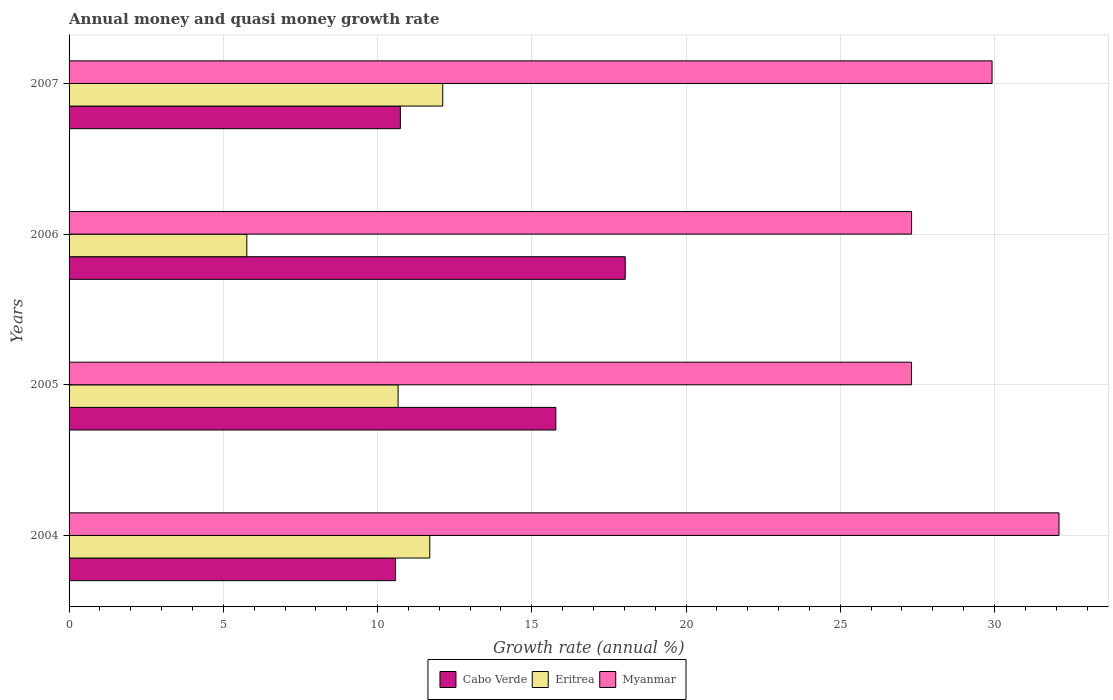How many different coloured bars are there?
Keep it short and to the point. 3. How many groups of bars are there?
Offer a terse response. 4. Are the number of bars on each tick of the Y-axis equal?
Your answer should be very brief. Yes. How many bars are there on the 1st tick from the top?
Ensure brevity in your answer.  3. How many bars are there on the 2nd tick from the bottom?
Provide a short and direct response. 3. In how many cases, is the number of bars for a given year not equal to the number of legend labels?
Provide a short and direct response. 0. What is the growth rate in Eritrea in 2006?
Offer a very short reply. 5.76. Across all years, what is the maximum growth rate in Cabo Verde?
Your answer should be compact. 18.03. Across all years, what is the minimum growth rate in Eritrea?
Provide a succinct answer. 5.76. In which year was the growth rate in Myanmar maximum?
Give a very brief answer. 2004. What is the total growth rate in Myanmar in the graph?
Offer a very short reply. 116.63. What is the difference between the growth rate in Myanmar in 2005 and that in 2006?
Ensure brevity in your answer.  -0. What is the difference between the growth rate in Myanmar in 2006 and the growth rate in Cabo Verde in 2007?
Ensure brevity in your answer.  16.57. What is the average growth rate in Cabo Verde per year?
Your answer should be very brief. 13.78. In the year 2004, what is the difference between the growth rate in Myanmar and growth rate in Eritrea?
Make the answer very short. 20.4. In how many years, is the growth rate in Myanmar greater than 10 %?
Offer a terse response. 4. What is the ratio of the growth rate in Eritrea in 2005 to that in 2006?
Your answer should be compact. 1.85. Is the growth rate in Eritrea in 2004 less than that in 2007?
Keep it short and to the point. Yes. Is the difference between the growth rate in Myanmar in 2006 and 2007 greater than the difference between the growth rate in Eritrea in 2006 and 2007?
Provide a succinct answer. Yes. What is the difference between the highest and the second highest growth rate in Cabo Verde?
Your answer should be compact. 2.25. What is the difference between the highest and the lowest growth rate in Eritrea?
Ensure brevity in your answer.  6.35. In how many years, is the growth rate in Cabo Verde greater than the average growth rate in Cabo Verde taken over all years?
Ensure brevity in your answer.  2. Is the sum of the growth rate in Myanmar in 2005 and 2006 greater than the maximum growth rate in Eritrea across all years?
Make the answer very short. Yes. What does the 1st bar from the top in 2006 represents?
Your answer should be compact. Myanmar. What does the 1st bar from the bottom in 2004 represents?
Offer a terse response. Cabo Verde. Is it the case that in every year, the sum of the growth rate in Eritrea and growth rate in Cabo Verde is greater than the growth rate in Myanmar?
Ensure brevity in your answer.  No. How many bars are there?
Give a very brief answer. 12. Are all the bars in the graph horizontal?
Offer a very short reply. Yes. How many years are there in the graph?
Provide a short and direct response. 4. What is the difference between two consecutive major ticks on the X-axis?
Keep it short and to the point. 5. Does the graph contain grids?
Offer a very short reply. Yes. Where does the legend appear in the graph?
Your response must be concise. Bottom center. How many legend labels are there?
Ensure brevity in your answer.  3. How are the legend labels stacked?
Provide a short and direct response. Horizontal. What is the title of the graph?
Provide a short and direct response. Annual money and quasi money growth rate. What is the label or title of the X-axis?
Provide a short and direct response. Growth rate (annual %). What is the Growth rate (annual %) in Cabo Verde in 2004?
Give a very brief answer. 10.58. What is the Growth rate (annual %) of Eritrea in 2004?
Provide a succinct answer. 11.69. What is the Growth rate (annual %) of Myanmar in 2004?
Ensure brevity in your answer.  32.09. What is the Growth rate (annual %) of Cabo Verde in 2005?
Keep it short and to the point. 15.78. What is the Growth rate (annual %) of Eritrea in 2005?
Give a very brief answer. 10.67. What is the Growth rate (annual %) of Myanmar in 2005?
Your answer should be very brief. 27.31. What is the Growth rate (annual %) in Cabo Verde in 2006?
Make the answer very short. 18.03. What is the Growth rate (annual %) of Eritrea in 2006?
Provide a short and direct response. 5.76. What is the Growth rate (annual %) of Myanmar in 2006?
Your answer should be very brief. 27.31. What is the Growth rate (annual %) of Cabo Verde in 2007?
Your answer should be very brief. 10.74. What is the Growth rate (annual %) in Eritrea in 2007?
Offer a very short reply. 12.11. What is the Growth rate (annual %) in Myanmar in 2007?
Offer a very short reply. 29.92. Across all years, what is the maximum Growth rate (annual %) in Cabo Verde?
Offer a very short reply. 18.03. Across all years, what is the maximum Growth rate (annual %) of Eritrea?
Your response must be concise. 12.11. Across all years, what is the maximum Growth rate (annual %) in Myanmar?
Ensure brevity in your answer.  32.09. Across all years, what is the minimum Growth rate (annual %) of Cabo Verde?
Give a very brief answer. 10.58. Across all years, what is the minimum Growth rate (annual %) in Eritrea?
Your answer should be compact. 5.76. Across all years, what is the minimum Growth rate (annual %) of Myanmar?
Your answer should be very brief. 27.31. What is the total Growth rate (annual %) in Cabo Verde in the graph?
Your answer should be very brief. 55.13. What is the total Growth rate (annual %) in Eritrea in the graph?
Provide a succinct answer. 40.24. What is the total Growth rate (annual %) in Myanmar in the graph?
Your answer should be very brief. 116.63. What is the difference between the Growth rate (annual %) of Cabo Verde in 2004 and that in 2005?
Offer a terse response. -5.2. What is the difference between the Growth rate (annual %) of Eritrea in 2004 and that in 2005?
Offer a terse response. 1.03. What is the difference between the Growth rate (annual %) of Myanmar in 2004 and that in 2005?
Make the answer very short. 4.78. What is the difference between the Growth rate (annual %) in Cabo Verde in 2004 and that in 2006?
Your response must be concise. -7.45. What is the difference between the Growth rate (annual %) of Eritrea in 2004 and that in 2006?
Give a very brief answer. 5.93. What is the difference between the Growth rate (annual %) of Myanmar in 2004 and that in 2006?
Your answer should be compact. 4.78. What is the difference between the Growth rate (annual %) of Cabo Verde in 2004 and that in 2007?
Your answer should be very brief. -0.16. What is the difference between the Growth rate (annual %) of Eritrea in 2004 and that in 2007?
Make the answer very short. -0.42. What is the difference between the Growth rate (annual %) in Myanmar in 2004 and that in 2007?
Your response must be concise. 2.17. What is the difference between the Growth rate (annual %) in Cabo Verde in 2005 and that in 2006?
Your answer should be very brief. -2.25. What is the difference between the Growth rate (annual %) of Eritrea in 2005 and that in 2006?
Provide a succinct answer. 4.9. What is the difference between the Growth rate (annual %) of Myanmar in 2005 and that in 2006?
Your answer should be very brief. -0. What is the difference between the Growth rate (annual %) of Cabo Verde in 2005 and that in 2007?
Make the answer very short. 5.04. What is the difference between the Growth rate (annual %) in Eritrea in 2005 and that in 2007?
Offer a terse response. -1.45. What is the difference between the Growth rate (annual %) in Myanmar in 2005 and that in 2007?
Your response must be concise. -2.61. What is the difference between the Growth rate (annual %) in Cabo Verde in 2006 and that in 2007?
Make the answer very short. 7.29. What is the difference between the Growth rate (annual %) of Eritrea in 2006 and that in 2007?
Ensure brevity in your answer.  -6.35. What is the difference between the Growth rate (annual %) of Myanmar in 2006 and that in 2007?
Your answer should be compact. -2.61. What is the difference between the Growth rate (annual %) in Cabo Verde in 2004 and the Growth rate (annual %) in Eritrea in 2005?
Offer a very short reply. -0.08. What is the difference between the Growth rate (annual %) of Cabo Verde in 2004 and the Growth rate (annual %) of Myanmar in 2005?
Make the answer very short. -16.73. What is the difference between the Growth rate (annual %) in Eritrea in 2004 and the Growth rate (annual %) in Myanmar in 2005?
Offer a terse response. -15.62. What is the difference between the Growth rate (annual %) of Cabo Verde in 2004 and the Growth rate (annual %) of Eritrea in 2006?
Provide a short and direct response. 4.82. What is the difference between the Growth rate (annual %) of Cabo Verde in 2004 and the Growth rate (annual %) of Myanmar in 2006?
Provide a short and direct response. -16.73. What is the difference between the Growth rate (annual %) of Eritrea in 2004 and the Growth rate (annual %) of Myanmar in 2006?
Offer a very short reply. -15.62. What is the difference between the Growth rate (annual %) of Cabo Verde in 2004 and the Growth rate (annual %) of Eritrea in 2007?
Keep it short and to the point. -1.53. What is the difference between the Growth rate (annual %) of Cabo Verde in 2004 and the Growth rate (annual %) of Myanmar in 2007?
Keep it short and to the point. -19.34. What is the difference between the Growth rate (annual %) in Eritrea in 2004 and the Growth rate (annual %) in Myanmar in 2007?
Ensure brevity in your answer.  -18.23. What is the difference between the Growth rate (annual %) in Cabo Verde in 2005 and the Growth rate (annual %) in Eritrea in 2006?
Give a very brief answer. 10.02. What is the difference between the Growth rate (annual %) in Cabo Verde in 2005 and the Growth rate (annual %) in Myanmar in 2006?
Your answer should be compact. -11.53. What is the difference between the Growth rate (annual %) of Eritrea in 2005 and the Growth rate (annual %) of Myanmar in 2006?
Provide a succinct answer. -16.65. What is the difference between the Growth rate (annual %) of Cabo Verde in 2005 and the Growth rate (annual %) of Eritrea in 2007?
Offer a very short reply. 3.67. What is the difference between the Growth rate (annual %) of Cabo Verde in 2005 and the Growth rate (annual %) of Myanmar in 2007?
Your answer should be compact. -14.14. What is the difference between the Growth rate (annual %) in Eritrea in 2005 and the Growth rate (annual %) in Myanmar in 2007?
Your answer should be very brief. -19.25. What is the difference between the Growth rate (annual %) in Cabo Verde in 2006 and the Growth rate (annual %) in Eritrea in 2007?
Keep it short and to the point. 5.92. What is the difference between the Growth rate (annual %) in Cabo Verde in 2006 and the Growth rate (annual %) in Myanmar in 2007?
Keep it short and to the point. -11.89. What is the difference between the Growth rate (annual %) in Eritrea in 2006 and the Growth rate (annual %) in Myanmar in 2007?
Your answer should be compact. -24.16. What is the average Growth rate (annual %) in Cabo Verde per year?
Keep it short and to the point. 13.78. What is the average Growth rate (annual %) of Eritrea per year?
Your answer should be compact. 10.06. What is the average Growth rate (annual %) in Myanmar per year?
Offer a very short reply. 29.16. In the year 2004, what is the difference between the Growth rate (annual %) of Cabo Verde and Growth rate (annual %) of Eritrea?
Offer a terse response. -1.11. In the year 2004, what is the difference between the Growth rate (annual %) in Cabo Verde and Growth rate (annual %) in Myanmar?
Your answer should be very brief. -21.51. In the year 2004, what is the difference between the Growth rate (annual %) in Eritrea and Growth rate (annual %) in Myanmar?
Your response must be concise. -20.4. In the year 2005, what is the difference between the Growth rate (annual %) of Cabo Verde and Growth rate (annual %) of Eritrea?
Offer a very short reply. 5.11. In the year 2005, what is the difference between the Growth rate (annual %) of Cabo Verde and Growth rate (annual %) of Myanmar?
Provide a short and direct response. -11.53. In the year 2005, what is the difference between the Growth rate (annual %) of Eritrea and Growth rate (annual %) of Myanmar?
Provide a short and direct response. -16.64. In the year 2006, what is the difference between the Growth rate (annual %) in Cabo Verde and Growth rate (annual %) in Eritrea?
Provide a succinct answer. 12.27. In the year 2006, what is the difference between the Growth rate (annual %) of Cabo Verde and Growth rate (annual %) of Myanmar?
Ensure brevity in your answer.  -9.28. In the year 2006, what is the difference between the Growth rate (annual %) in Eritrea and Growth rate (annual %) in Myanmar?
Provide a short and direct response. -21.55. In the year 2007, what is the difference between the Growth rate (annual %) of Cabo Verde and Growth rate (annual %) of Eritrea?
Give a very brief answer. -1.37. In the year 2007, what is the difference between the Growth rate (annual %) of Cabo Verde and Growth rate (annual %) of Myanmar?
Offer a terse response. -19.18. In the year 2007, what is the difference between the Growth rate (annual %) in Eritrea and Growth rate (annual %) in Myanmar?
Make the answer very short. -17.81. What is the ratio of the Growth rate (annual %) of Cabo Verde in 2004 to that in 2005?
Give a very brief answer. 0.67. What is the ratio of the Growth rate (annual %) in Eritrea in 2004 to that in 2005?
Offer a very short reply. 1.1. What is the ratio of the Growth rate (annual %) of Myanmar in 2004 to that in 2005?
Make the answer very short. 1.18. What is the ratio of the Growth rate (annual %) in Cabo Verde in 2004 to that in 2006?
Provide a succinct answer. 0.59. What is the ratio of the Growth rate (annual %) in Eritrea in 2004 to that in 2006?
Make the answer very short. 2.03. What is the ratio of the Growth rate (annual %) of Myanmar in 2004 to that in 2006?
Your answer should be compact. 1.18. What is the ratio of the Growth rate (annual %) of Cabo Verde in 2004 to that in 2007?
Provide a succinct answer. 0.99. What is the ratio of the Growth rate (annual %) in Eritrea in 2004 to that in 2007?
Your answer should be compact. 0.97. What is the ratio of the Growth rate (annual %) of Myanmar in 2004 to that in 2007?
Keep it short and to the point. 1.07. What is the ratio of the Growth rate (annual %) of Cabo Verde in 2005 to that in 2006?
Provide a short and direct response. 0.88. What is the ratio of the Growth rate (annual %) of Eritrea in 2005 to that in 2006?
Provide a succinct answer. 1.85. What is the ratio of the Growth rate (annual %) in Myanmar in 2005 to that in 2006?
Ensure brevity in your answer.  1. What is the ratio of the Growth rate (annual %) of Cabo Verde in 2005 to that in 2007?
Offer a terse response. 1.47. What is the ratio of the Growth rate (annual %) in Eritrea in 2005 to that in 2007?
Offer a terse response. 0.88. What is the ratio of the Growth rate (annual %) in Myanmar in 2005 to that in 2007?
Make the answer very short. 0.91. What is the ratio of the Growth rate (annual %) of Cabo Verde in 2006 to that in 2007?
Your answer should be very brief. 1.68. What is the ratio of the Growth rate (annual %) of Eritrea in 2006 to that in 2007?
Make the answer very short. 0.48. What is the ratio of the Growth rate (annual %) in Myanmar in 2006 to that in 2007?
Ensure brevity in your answer.  0.91. What is the difference between the highest and the second highest Growth rate (annual %) in Cabo Verde?
Offer a very short reply. 2.25. What is the difference between the highest and the second highest Growth rate (annual %) of Eritrea?
Your response must be concise. 0.42. What is the difference between the highest and the second highest Growth rate (annual %) of Myanmar?
Offer a very short reply. 2.17. What is the difference between the highest and the lowest Growth rate (annual %) in Cabo Verde?
Provide a succinct answer. 7.45. What is the difference between the highest and the lowest Growth rate (annual %) of Eritrea?
Offer a terse response. 6.35. What is the difference between the highest and the lowest Growth rate (annual %) of Myanmar?
Provide a succinct answer. 4.78. 